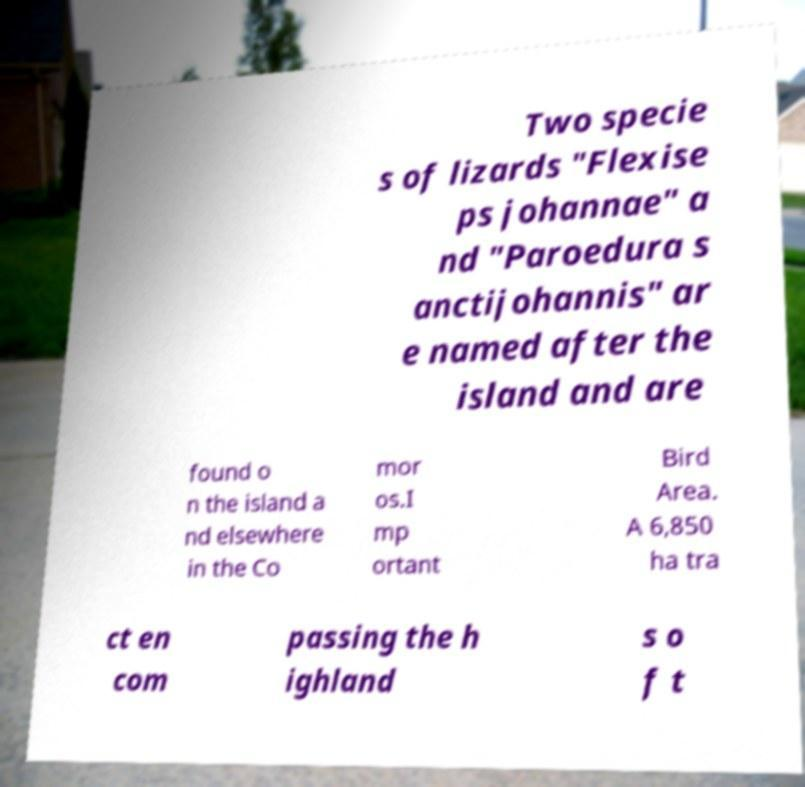Can you accurately transcribe the text from the provided image for me? Two specie s of lizards "Flexise ps johannae" a nd "Paroedura s anctijohannis" ar e named after the island and are found o n the island a nd elsewhere in the Co mor os.I mp ortant Bird Area. A 6,850 ha tra ct en com passing the h ighland s o f t 